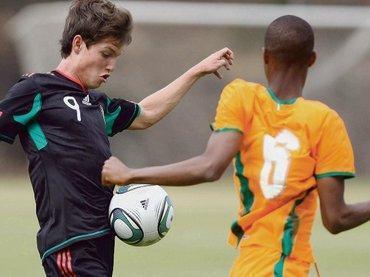How many men in the picture?
Give a very brief answer. 2. How many people are in the picture?
Give a very brief answer. 2. 